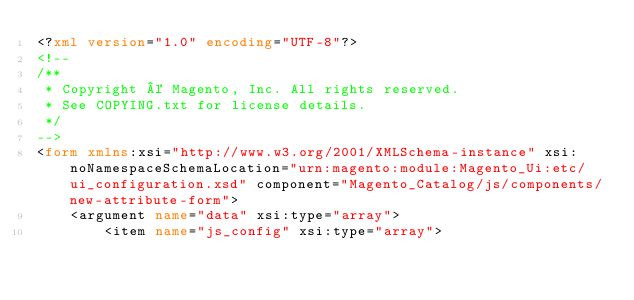Convert code to text. <code><loc_0><loc_0><loc_500><loc_500><_XML_><?xml version="1.0" encoding="UTF-8"?>
<!--
/**
 * Copyright © Magento, Inc. All rights reserved.
 * See COPYING.txt for license details.
 */
-->
<form xmlns:xsi="http://www.w3.org/2001/XMLSchema-instance" xsi:noNamespaceSchemaLocation="urn:magento:module:Magento_Ui:etc/ui_configuration.xsd" component="Magento_Catalog/js/components/new-attribute-form">
    <argument name="data" xsi:type="array">
        <item name="js_config" xsi:type="array"></code> 